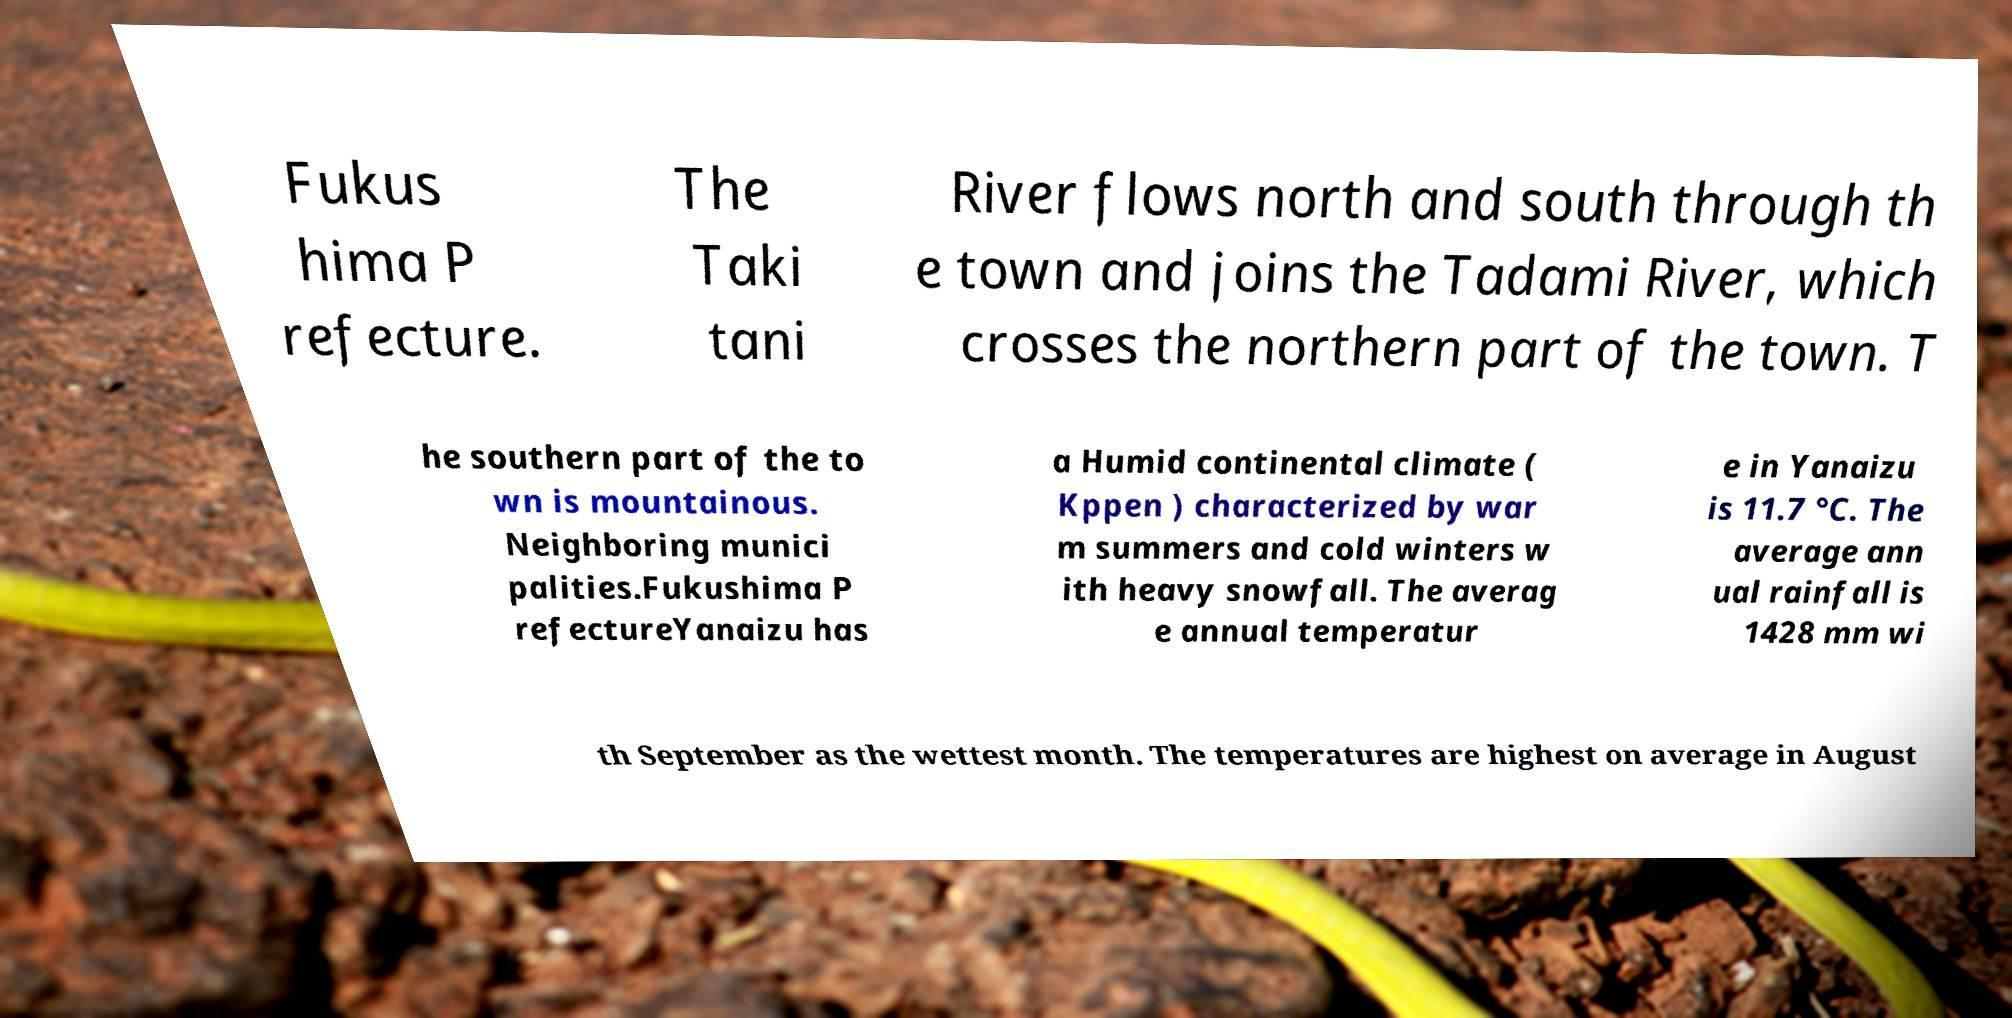Could you extract and type out the text from this image? Fukus hima P refecture. The Taki tani River flows north and south through th e town and joins the Tadami River, which crosses the northern part of the town. T he southern part of the to wn is mountainous. Neighboring munici palities.Fukushima P refectureYanaizu has a Humid continental climate ( Kppen ) characterized by war m summers and cold winters w ith heavy snowfall. The averag e annual temperatur e in Yanaizu is 11.7 °C. The average ann ual rainfall is 1428 mm wi th September as the wettest month. The temperatures are highest on average in August 